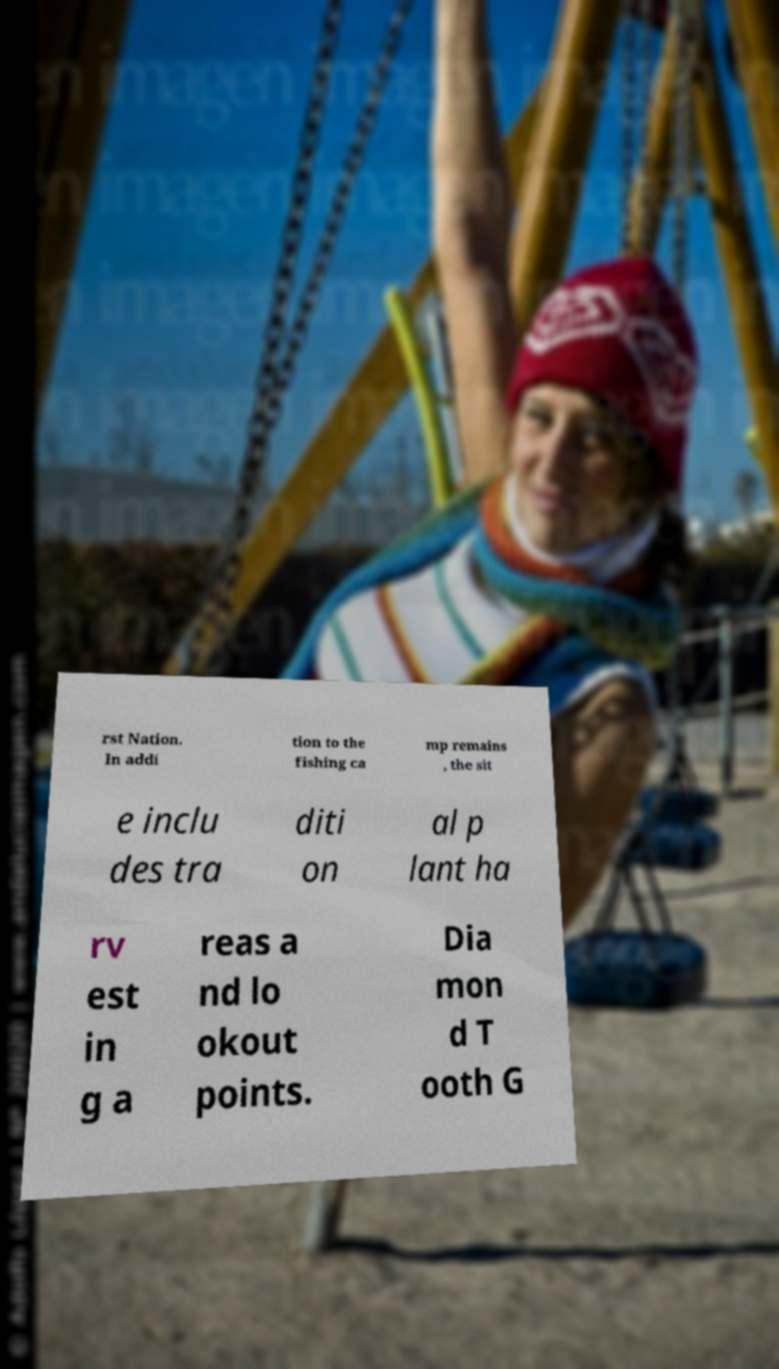There's text embedded in this image that I need extracted. Can you transcribe it verbatim? rst Nation. In addi tion to the fishing ca mp remains , the sit e inclu des tra diti on al p lant ha rv est in g a reas a nd lo okout points. Dia mon d T ooth G 